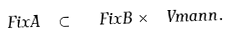Convert formula to latex. <formula><loc_0><loc_0><loc_500><loc_500>\ F i x A \ \subset \ \ F i x B \times \ V m a n n .</formula> 